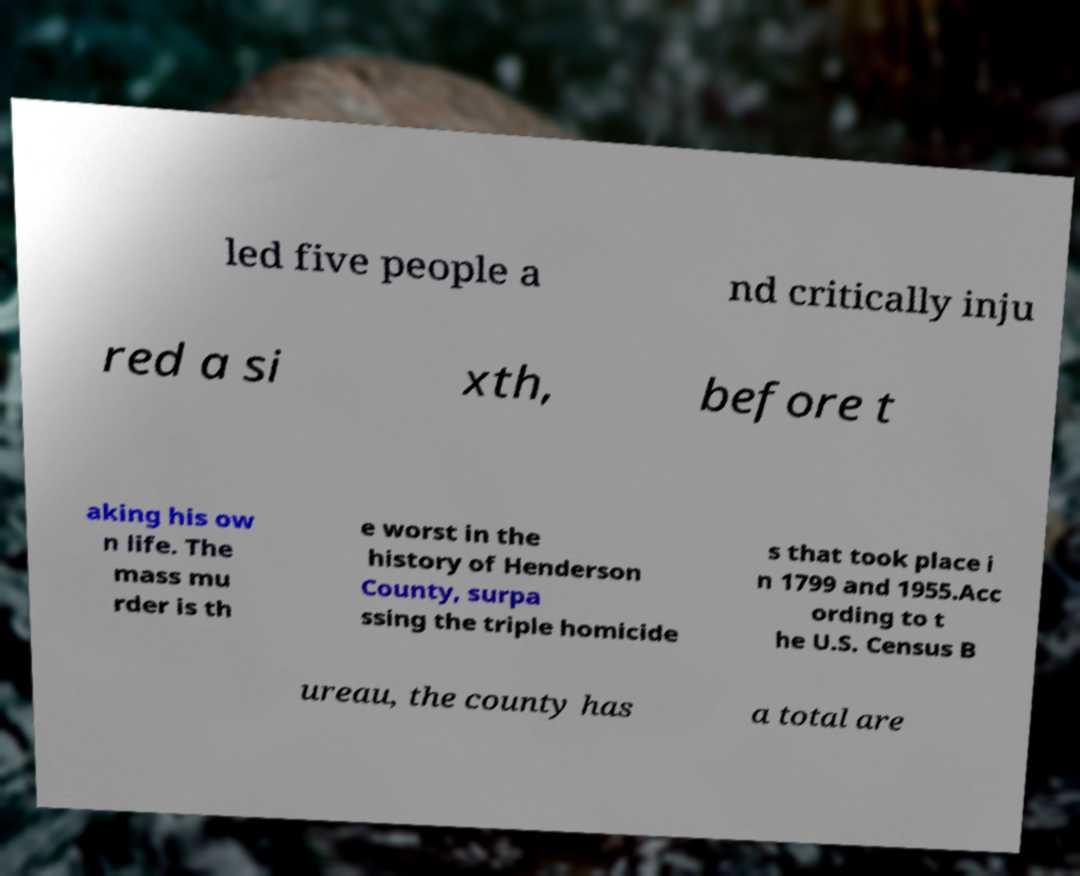Could you extract and type out the text from this image? led five people a nd critically inju red a si xth, before t aking his ow n life. The mass mu rder is th e worst in the history of Henderson County, surpa ssing the triple homicide s that took place i n 1799 and 1955.Acc ording to t he U.S. Census B ureau, the county has a total are 